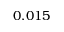<formula> <loc_0><loc_0><loc_500><loc_500>0 . 0 1 5</formula> 